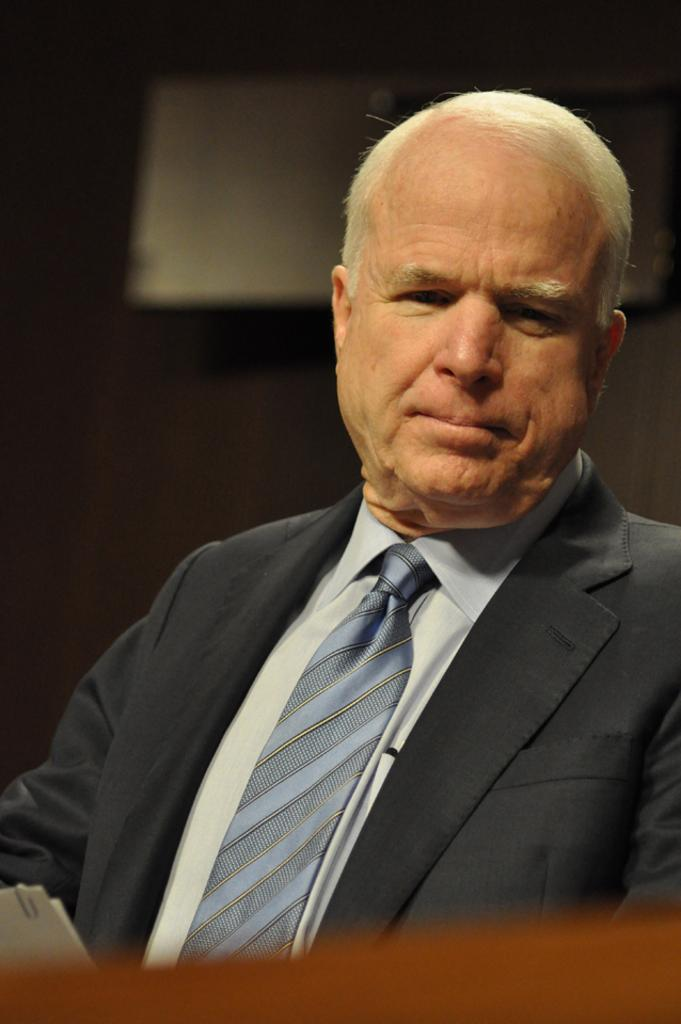What is the man in the image doing? The man is sitting in the image. How would you describe the background of the image? The background of the image is dark. Can you identify any objects in the background of the image? Yes, there is an object visible in the background of the image. What type of glove is the man wearing in the image? There is no glove mentioned or visible in the image. How does the cracker contribute to the expansion of the universe in the image? There is no mention of a cracker or any expansion in the image. 